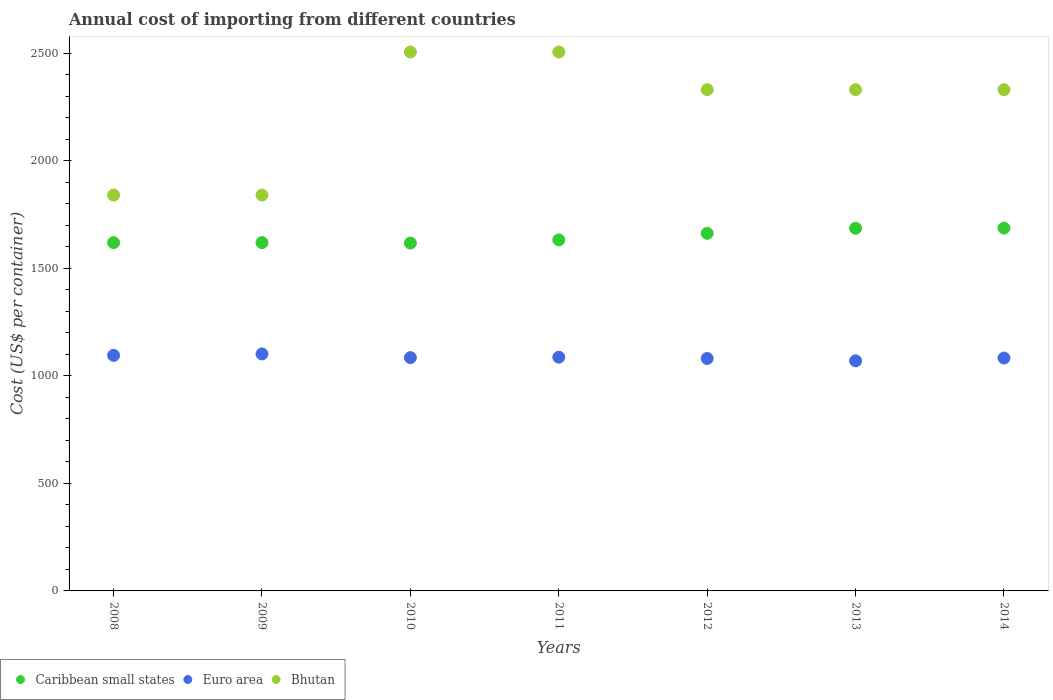How many different coloured dotlines are there?
Offer a very short reply. 3. Is the number of dotlines equal to the number of legend labels?
Offer a terse response. Yes. What is the total annual cost of importing in Caribbean small states in 2014?
Your response must be concise. 1686.54. Across all years, what is the maximum total annual cost of importing in Euro area?
Offer a terse response. 1101.44. Across all years, what is the minimum total annual cost of importing in Caribbean small states?
Your response must be concise. 1616.92. In which year was the total annual cost of importing in Caribbean small states maximum?
Provide a short and direct response. 2014. In which year was the total annual cost of importing in Bhutan minimum?
Offer a terse response. 2008. What is the total total annual cost of importing in Bhutan in the graph?
Ensure brevity in your answer.  1.57e+04. What is the difference between the total annual cost of importing in Caribbean small states in 2013 and that in 2014?
Provide a short and direct response. -0.77. What is the difference between the total annual cost of importing in Bhutan in 2013 and the total annual cost of importing in Euro area in 2012?
Make the answer very short. 1249.58. What is the average total annual cost of importing in Euro area per year?
Ensure brevity in your answer.  1085.68. In the year 2014, what is the difference between the total annual cost of importing in Euro area and total annual cost of importing in Bhutan?
Your answer should be compact. -1247.53. In how many years, is the total annual cost of importing in Euro area greater than 900 US$?
Keep it short and to the point. 7. What is the ratio of the total annual cost of importing in Euro area in 2012 to that in 2014?
Provide a succinct answer. 1. Is the total annual cost of importing in Caribbean small states in 2008 less than that in 2010?
Provide a short and direct response. No. What is the difference between the highest and the second highest total annual cost of importing in Euro area?
Provide a succinct answer. 6.5. What is the difference between the highest and the lowest total annual cost of importing in Euro area?
Give a very brief answer. 31.87. In how many years, is the total annual cost of importing in Bhutan greater than the average total annual cost of importing in Bhutan taken over all years?
Your response must be concise. 5. Is the sum of the total annual cost of importing in Bhutan in 2011 and 2013 greater than the maximum total annual cost of importing in Euro area across all years?
Give a very brief answer. Yes. Is it the case that in every year, the sum of the total annual cost of importing in Caribbean small states and total annual cost of importing in Bhutan  is greater than the total annual cost of importing in Euro area?
Your response must be concise. Yes. Is the total annual cost of importing in Bhutan strictly less than the total annual cost of importing in Caribbean small states over the years?
Make the answer very short. No. How many dotlines are there?
Ensure brevity in your answer.  3. How many years are there in the graph?
Your answer should be very brief. 7. What is the difference between two consecutive major ticks on the Y-axis?
Provide a short and direct response. 500. Does the graph contain any zero values?
Offer a terse response. No. Does the graph contain grids?
Keep it short and to the point. No. How many legend labels are there?
Give a very brief answer. 3. How are the legend labels stacked?
Ensure brevity in your answer.  Horizontal. What is the title of the graph?
Provide a succinct answer. Annual cost of importing from different countries. Does "Turks and Caicos Islands" appear as one of the legend labels in the graph?
Give a very brief answer. No. What is the label or title of the X-axis?
Offer a very short reply. Years. What is the label or title of the Y-axis?
Offer a very short reply. Cost (US$ per container). What is the Cost (US$ per container) in Caribbean small states in 2008?
Ensure brevity in your answer.  1619. What is the Cost (US$ per container) in Euro area in 2008?
Make the answer very short. 1094.94. What is the Cost (US$ per container) of Bhutan in 2008?
Provide a short and direct response. 1840. What is the Cost (US$ per container) in Caribbean small states in 2009?
Provide a short and direct response. 1619. What is the Cost (US$ per container) of Euro area in 2009?
Ensure brevity in your answer.  1101.44. What is the Cost (US$ per container) of Bhutan in 2009?
Ensure brevity in your answer.  1840. What is the Cost (US$ per container) in Caribbean small states in 2010?
Your answer should be very brief. 1616.92. What is the Cost (US$ per container) in Euro area in 2010?
Offer a terse response. 1084.44. What is the Cost (US$ per container) of Bhutan in 2010?
Offer a terse response. 2505. What is the Cost (US$ per container) in Caribbean small states in 2011?
Keep it short and to the point. 1631.77. What is the Cost (US$ per container) in Euro area in 2011?
Offer a very short reply. 1086.47. What is the Cost (US$ per container) in Bhutan in 2011?
Ensure brevity in your answer.  2505. What is the Cost (US$ per container) of Caribbean small states in 2012?
Ensure brevity in your answer.  1662.31. What is the Cost (US$ per container) of Euro area in 2012?
Provide a short and direct response. 1080.42. What is the Cost (US$ per container) in Bhutan in 2012?
Ensure brevity in your answer.  2330. What is the Cost (US$ per container) in Caribbean small states in 2013?
Offer a very short reply. 1685.77. What is the Cost (US$ per container) in Euro area in 2013?
Ensure brevity in your answer.  1069.58. What is the Cost (US$ per container) in Bhutan in 2013?
Keep it short and to the point. 2330. What is the Cost (US$ per container) in Caribbean small states in 2014?
Offer a terse response. 1686.54. What is the Cost (US$ per container) of Euro area in 2014?
Make the answer very short. 1082.47. What is the Cost (US$ per container) of Bhutan in 2014?
Your response must be concise. 2330. Across all years, what is the maximum Cost (US$ per container) in Caribbean small states?
Your answer should be very brief. 1686.54. Across all years, what is the maximum Cost (US$ per container) of Euro area?
Offer a very short reply. 1101.44. Across all years, what is the maximum Cost (US$ per container) of Bhutan?
Keep it short and to the point. 2505. Across all years, what is the minimum Cost (US$ per container) in Caribbean small states?
Keep it short and to the point. 1616.92. Across all years, what is the minimum Cost (US$ per container) of Euro area?
Offer a terse response. 1069.58. Across all years, what is the minimum Cost (US$ per container) in Bhutan?
Give a very brief answer. 1840. What is the total Cost (US$ per container) in Caribbean small states in the graph?
Provide a succinct answer. 1.15e+04. What is the total Cost (US$ per container) of Euro area in the graph?
Ensure brevity in your answer.  7599.78. What is the total Cost (US$ per container) of Bhutan in the graph?
Keep it short and to the point. 1.57e+04. What is the difference between the Cost (US$ per container) in Bhutan in 2008 and that in 2009?
Keep it short and to the point. 0. What is the difference between the Cost (US$ per container) in Caribbean small states in 2008 and that in 2010?
Ensure brevity in your answer.  2.08. What is the difference between the Cost (US$ per container) in Euro area in 2008 and that in 2010?
Offer a very short reply. 10.5. What is the difference between the Cost (US$ per container) in Bhutan in 2008 and that in 2010?
Provide a short and direct response. -665. What is the difference between the Cost (US$ per container) in Caribbean small states in 2008 and that in 2011?
Give a very brief answer. -12.77. What is the difference between the Cost (US$ per container) in Euro area in 2008 and that in 2011?
Make the answer very short. 8.47. What is the difference between the Cost (US$ per container) of Bhutan in 2008 and that in 2011?
Your response must be concise. -665. What is the difference between the Cost (US$ per container) of Caribbean small states in 2008 and that in 2012?
Your answer should be very brief. -43.31. What is the difference between the Cost (US$ per container) of Euro area in 2008 and that in 2012?
Give a very brief answer. 14.52. What is the difference between the Cost (US$ per container) in Bhutan in 2008 and that in 2012?
Keep it short and to the point. -490. What is the difference between the Cost (US$ per container) in Caribbean small states in 2008 and that in 2013?
Your response must be concise. -66.77. What is the difference between the Cost (US$ per container) of Euro area in 2008 and that in 2013?
Your response must be concise. 25.37. What is the difference between the Cost (US$ per container) of Bhutan in 2008 and that in 2013?
Offer a terse response. -490. What is the difference between the Cost (US$ per container) in Caribbean small states in 2008 and that in 2014?
Your answer should be very brief. -67.54. What is the difference between the Cost (US$ per container) in Euro area in 2008 and that in 2014?
Your answer should be compact. 12.47. What is the difference between the Cost (US$ per container) in Bhutan in 2008 and that in 2014?
Provide a short and direct response. -490. What is the difference between the Cost (US$ per container) of Caribbean small states in 2009 and that in 2010?
Give a very brief answer. 2.08. What is the difference between the Cost (US$ per container) in Euro area in 2009 and that in 2010?
Offer a very short reply. 17. What is the difference between the Cost (US$ per container) of Bhutan in 2009 and that in 2010?
Ensure brevity in your answer.  -665. What is the difference between the Cost (US$ per container) of Caribbean small states in 2009 and that in 2011?
Ensure brevity in your answer.  -12.77. What is the difference between the Cost (US$ per container) of Euro area in 2009 and that in 2011?
Your answer should be very brief. 14.97. What is the difference between the Cost (US$ per container) in Bhutan in 2009 and that in 2011?
Offer a terse response. -665. What is the difference between the Cost (US$ per container) in Caribbean small states in 2009 and that in 2012?
Provide a succinct answer. -43.31. What is the difference between the Cost (US$ per container) of Euro area in 2009 and that in 2012?
Offer a very short reply. 21.02. What is the difference between the Cost (US$ per container) in Bhutan in 2009 and that in 2012?
Provide a short and direct response. -490. What is the difference between the Cost (US$ per container) of Caribbean small states in 2009 and that in 2013?
Offer a very short reply. -66.77. What is the difference between the Cost (US$ per container) of Euro area in 2009 and that in 2013?
Offer a terse response. 31.87. What is the difference between the Cost (US$ per container) in Bhutan in 2009 and that in 2013?
Your answer should be compact. -490. What is the difference between the Cost (US$ per container) of Caribbean small states in 2009 and that in 2014?
Make the answer very short. -67.54. What is the difference between the Cost (US$ per container) of Euro area in 2009 and that in 2014?
Offer a terse response. 18.97. What is the difference between the Cost (US$ per container) in Bhutan in 2009 and that in 2014?
Offer a very short reply. -490. What is the difference between the Cost (US$ per container) of Caribbean small states in 2010 and that in 2011?
Make the answer very short. -14.85. What is the difference between the Cost (US$ per container) of Euro area in 2010 and that in 2011?
Offer a terse response. -2.03. What is the difference between the Cost (US$ per container) in Caribbean small states in 2010 and that in 2012?
Provide a succinct answer. -45.39. What is the difference between the Cost (US$ per container) of Euro area in 2010 and that in 2012?
Ensure brevity in your answer.  4.02. What is the difference between the Cost (US$ per container) of Bhutan in 2010 and that in 2012?
Provide a succinct answer. 175. What is the difference between the Cost (US$ per container) of Caribbean small states in 2010 and that in 2013?
Your answer should be compact. -68.85. What is the difference between the Cost (US$ per container) in Euro area in 2010 and that in 2013?
Provide a short and direct response. 14.87. What is the difference between the Cost (US$ per container) of Bhutan in 2010 and that in 2013?
Ensure brevity in your answer.  175. What is the difference between the Cost (US$ per container) in Caribbean small states in 2010 and that in 2014?
Provide a short and direct response. -69.62. What is the difference between the Cost (US$ per container) in Euro area in 2010 and that in 2014?
Your answer should be very brief. 1.97. What is the difference between the Cost (US$ per container) in Bhutan in 2010 and that in 2014?
Keep it short and to the point. 175. What is the difference between the Cost (US$ per container) of Caribbean small states in 2011 and that in 2012?
Keep it short and to the point. -30.54. What is the difference between the Cost (US$ per container) in Euro area in 2011 and that in 2012?
Offer a very short reply. 6.05. What is the difference between the Cost (US$ per container) in Bhutan in 2011 and that in 2012?
Ensure brevity in your answer.  175. What is the difference between the Cost (US$ per container) in Caribbean small states in 2011 and that in 2013?
Offer a terse response. -54. What is the difference between the Cost (US$ per container) of Euro area in 2011 and that in 2013?
Offer a very short reply. 16.89. What is the difference between the Cost (US$ per container) in Bhutan in 2011 and that in 2013?
Your answer should be compact. 175. What is the difference between the Cost (US$ per container) of Caribbean small states in 2011 and that in 2014?
Provide a short and direct response. -54.77. What is the difference between the Cost (US$ per container) of Bhutan in 2011 and that in 2014?
Provide a short and direct response. 175. What is the difference between the Cost (US$ per container) in Caribbean small states in 2012 and that in 2013?
Give a very brief answer. -23.46. What is the difference between the Cost (US$ per container) of Euro area in 2012 and that in 2013?
Offer a very short reply. 10.84. What is the difference between the Cost (US$ per container) of Caribbean small states in 2012 and that in 2014?
Offer a very short reply. -24.23. What is the difference between the Cost (US$ per container) of Euro area in 2012 and that in 2014?
Your answer should be compact. -2.05. What is the difference between the Cost (US$ per container) of Bhutan in 2012 and that in 2014?
Make the answer very short. 0. What is the difference between the Cost (US$ per container) of Caribbean small states in 2013 and that in 2014?
Keep it short and to the point. -0.77. What is the difference between the Cost (US$ per container) of Euro area in 2013 and that in 2014?
Your response must be concise. -12.89. What is the difference between the Cost (US$ per container) in Bhutan in 2013 and that in 2014?
Your answer should be very brief. 0. What is the difference between the Cost (US$ per container) of Caribbean small states in 2008 and the Cost (US$ per container) of Euro area in 2009?
Offer a very short reply. 517.56. What is the difference between the Cost (US$ per container) in Caribbean small states in 2008 and the Cost (US$ per container) in Bhutan in 2009?
Ensure brevity in your answer.  -221. What is the difference between the Cost (US$ per container) of Euro area in 2008 and the Cost (US$ per container) of Bhutan in 2009?
Provide a succinct answer. -745.06. What is the difference between the Cost (US$ per container) of Caribbean small states in 2008 and the Cost (US$ per container) of Euro area in 2010?
Make the answer very short. 534.56. What is the difference between the Cost (US$ per container) in Caribbean small states in 2008 and the Cost (US$ per container) in Bhutan in 2010?
Offer a very short reply. -886. What is the difference between the Cost (US$ per container) of Euro area in 2008 and the Cost (US$ per container) of Bhutan in 2010?
Offer a very short reply. -1410.06. What is the difference between the Cost (US$ per container) of Caribbean small states in 2008 and the Cost (US$ per container) of Euro area in 2011?
Offer a terse response. 532.53. What is the difference between the Cost (US$ per container) of Caribbean small states in 2008 and the Cost (US$ per container) of Bhutan in 2011?
Keep it short and to the point. -886. What is the difference between the Cost (US$ per container) in Euro area in 2008 and the Cost (US$ per container) in Bhutan in 2011?
Make the answer very short. -1410.06. What is the difference between the Cost (US$ per container) in Caribbean small states in 2008 and the Cost (US$ per container) in Euro area in 2012?
Your answer should be compact. 538.58. What is the difference between the Cost (US$ per container) in Caribbean small states in 2008 and the Cost (US$ per container) in Bhutan in 2012?
Your answer should be very brief. -711. What is the difference between the Cost (US$ per container) of Euro area in 2008 and the Cost (US$ per container) of Bhutan in 2012?
Offer a terse response. -1235.06. What is the difference between the Cost (US$ per container) of Caribbean small states in 2008 and the Cost (US$ per container) of Euro area in 2013?
Your answer should be compact. 549.42. What is the difference between the Cost (US$ per container) of Caribbean small states in 2008 and the Cost (US$ per container) of Bhutan in 2013?
Offer a very short reply. -711. What is the difference between the Cost (US$ per container) of Euro area in 2008 and the Cost (US$ per container) of Bhutan in 2013?
Make the answer very short. -1235.06. What is the difference between the Cost (US$ per container) of Caribbean small states in 2008 and the Cost (US$ per container) of Euro area in 2014?
Offer a very short reply. 536.53. What is the difference between the Cost (US$ per container) of Caribbean small states in 2008 and the Cost (US$ per container) of Bhutan in 2014?
Offer a terse response. -711. What is the difference between the Cost (US$ per container) of Euro area in 2008 and the Cost (US$ per container) of Bhutan in 2014?
Provide a short and direct response. -1235.06. What is the difference between the Cost (US$ per container) in Caribbean small states in 2009 and the Cost (US$ per container) in Euro area in 2010?
Your response must be concise. 534.56. What is the difference between the Cost (US$ per container) of Caribbean small states in 2009 and the Cost (US$ per container) of Bhutan in 2010?
Offer a very short reply. -886. What is the difference between the Cost (US$ per container) in Euro area in 2009 and the Cost (US$ per container) in Bhutan in 2010?
Keep it short and to the point. -1403.56. What is the difference between the Cost (US$ per container) of Caribbean small states in 2009 and the Cost (US$ per container) of Euro area in 2011?
Keep it short and to the point. 532.53. What is the difference between the Cost (US$ per container) of Caribbean small states in 2009 and the Cost (US$ per container) of Bhutan in 2011?
Make the answer very short. -886. What is the difference between the Cost (US$ per container) of Euro area in 2009 and the Cost (US$ per container) of Bhutan in 2011?
Your answer should be compact. -1403.56. What is the difference between the Cost (US$ per container) of Caribbean small states in 2009 and the Cost (US$ per container) of Euro area in 2012?
Your answer should be compact. 538.58. What is the difference between the Cost (US$ per container) in Caribbean small states in 2009 and the Cost (US$ per container) in Bhutan in 2012?
Your answer should be very brief. -711. What is the difference between the Cost (US$ per container) in Euro area in 2009 and the Cost (US$ per container) in Bhutan in 2012?
Ensure brevity in your answer.  -1228.56. What is the difference between the Cost (US$ per container) of Caribbean small states in 2009 and the Cost (US$ per container) of Euro area in 2013?
Provide a succinct answer. 549.42. What is the difference between the Cost (US$ per container) of Caribbean small states in 2009 and the Cost (US$ per container) of Bhutan in 2013?
Ensure brevity in your answer.  -711. What is the difference between the Cost (US$ per container) of Euro area in 2009 and the Cost (US$ per container) of Bhutan in 2013?
Offer a terse response. -1228.56. What is the difference between the Cost (US$ per container) of Caribbean small states in 2009 and the Cost (US$ per container) of Euro area in 2014?
Make the answer very short. 536.53. What is the difference between the Cost (US$ per container) of Caribbean small states in 2009 and the Cost (US$ per container) of Bhutan in 2014?
Provide a succinct answer. -711. What is the difference between the Cost (US$ per container) of Euro area in 2009 and the Cost (US$ per container) of Bhutan in 2014?
Offer a very short reply. -1228.56. What is the difference between the Cost (US$ per container) in Caribbean small states in 2010 and the Cost (US$ per container) in Euro area in 2011?
Provide a short and direct response. 530.44. What is the difference between the Cost (US$ per container) in Caribbean small states in 2010 and the Cost (US$ per container) in Bhutan in 2011?
Provide a succinct answer. -888.08. What is the difference between the Cost (US$ per container) in Euro area in 2010 and the Cost (US$ per container) in Bhutan in 2011?
Keep it short and to the point. -1420.56. What is the difference between the Cost (US$ per container) of Caribbean small states in 2010 and the Cost (US$ per container) of Euro area in 2012?
Your response must be concise. 536.5. What is the difference between the Cost (US$ per container) of Caribbean small states in 2010 and the Cost (US$ per container) of Bhutan in 2012?
Give a very brief answer. -713.08. What is the difference between the Cost (US$ per container) of Euro area in 2010 and the Cost (US$ per container) of Bhutan in 2012?
Provide a short and direct response. -1245.56. What is the difference between the Cost (US$ per container) of Caribbean small states in 2010 and the Cost (US$ per container) of Euro area in 2013?
Ensure brevity in your answer.  547.34. What is the difference between the Cost (US$ per container) in Caribbean small states in 2010 and the Cost (US$ per container) in Bhutan in 2013?
Provide a short and direct response. -713.08. What is the difference between the Cost (US$ per container) in Euro area in 2010 and the Cost (US$ per container) in Bhutan in 2013?
Your response must be concise. -1245.56. What is the difference between the Cost (US$ per container) of Caribbean small states in 2010 and the Cost (US$ per container) of Euro area in 2014?
Ensure brevity in your answer.  534.44. What is the difference between the Cost (US$ per container) in Caribbean small states in 2010 and the Cost (US$ per container) in Bhutan in 2014?
Your answer should be compact. -713.08. What is the difference between the Cost (US$ per container) of Euro area in 2010 and the Cost (US$ per container) of Bhutan in 2014?
Provide a short and direct response. -1245.56. What is the difference between the Cost (US$ per container) in Caribbean small states in 2011 and the Cost (US$ per container) in Euro area in 2012?
Provide a short and direct response. 551.35. What is the difference between the Cost (US$ per container) of Caribbean small states in 2011 and the Cost (US$ per container) of Bhutan in 2012?
Keep it short and to the point. -698.23. What is the difference between the Cost (US$ per container) in Euro area in 2011 and the Cost (US$ per container) in Bhutan in 2012?
Offer a terse response. -1243.53. What is the difference between the Cost (US$ per container) in Caribbean small states in 2011 and the Cost (US$ per container) in Euro area in 2013?
Your response must be concise. 562.19. What is the difference between the Cost (US$ per container) in Caribbean small states in 2011 and the Cost (US$ per container) in Bhutan in 2013?
Your response must be concise. -698.23. What is the difference between the Cost (US$ per container) in Euro area in 2011 and the Cost (US$ per container) in Bhutan in 2013?
Provide a succinct answer. -1243.53. What is the difference between the Cost (US$ per container) in Caribbean small states in 2011 and the Cost (US$ per container) in Euro area in 2014?
Your response must be concise. 549.3. What is the difference between the Cost (US$ per container) in Caribbean small states in 2011 and the Cost (US$ per container) in Bhutan in 2014?
Ensure brevity in your answer.  -698.23. What is the difference between the Cost (US$ per container) of Euro area in 2011 and the Cost (US$ per container) of Bhutan in 2014?
Provide a succinct answer. -1243.53. What is the difference between the Cost (US$ per container) of Caribbean small states in 2012 and the Cost (US$ per container) of Euro area in 2013?
Offer a very short reply. 592.73. What is the difference between the Cost (US$ per container) of Caribbean small states in 2012 and the Cost (US$ per container) of Bhutan in 2013?
Make the answer very short. -667.69. What is the difference between the Cost (US$ per container) of Euro area in 2012 and the Cost (US$ per container) of Bhutan in 2013?
Provide a succinct answer. -1249.58. What is the difference between the Cost (US$ per container) of Caribbean small states in 2012 and the Cost (US$ per container) of Euro area in 2014?
Provide a succinct answer. 579.83. What is the difference between the Cost (US$ per container) in Caribbean small states in 2012 and the Cost (US$ per container) in Bhutan in 2014?
Your answer should be compact. -667.69. What is the difference between the Cost (US$ per container) of Euro area in 2012 and the Cost (US$ per container) of Bhutan in 2014?
Your answer should be compact. -1249.58. What is the difference between the Cost (US$ per container) of Caribbean small states in 2013 and the Cost (US$ per container) of Euro area in 2014?
Offer a terse response. 603.3. What is the difference between the Cost (US$ per container) in Caribbean small states in 2013 and the Cost (US$ per container) in Bhutan in 2014?
Make the answer very short. -644.23. What is the difference between the Cost (US$ per container) of Euro area in 2013 and the Cost (US$ per container) of Bhutan in 2014?
Give a very brief answer. -1260.42. What is the average Cost (US$ per container) of Caribbean small states per year?
Offer a very short reply. 1645.9. What is the average Cost (US$ per container) of Euro area per year?
Offer a very short reply. 1085.68. What is the average Cost (US$ per container) of Bhutan per year?
Your answer should be compact. 2240. In the year 2008, what is the difference between the Cost (US$ per container) in Caribbean small states and Cost (US$ per container) in Euro area?
Your response must be concise. 524.06. In the year 2008, what is the difference between the Cost (US$ per container) of Caribbean small states and Cost (US$ per container) of Bhutan?
Provide a short and direct response. -221. In the year 2008, what is the difference between the Cost (US$ per container) in Euro area and Cost (US$ per container) in Bhutan?
Your response must be concise. -745.06. In the year 2009, what is the difference between the Cost (US$ per container) in Caribbean small states and Cost (US$ per container) in Euro area?
Provide a succinct answer. 517.56. In the year 2009, what is the difference between the Cost (US$ per container) in Caribbean small states and Cost (US$ per container) in Bhutan?
Provide a succinct answer. -221. In the year 2009, what is the difference between the Cost (US$ per container) in Euro area and Cost (US$ per container) in Bhutan?
Offer a very short reply. -738.56. In the year 2010, what is the difference between the Cost (US$ per container) in Caribbean small states and Cost (US$ per container) in Euro area?
Your answer should be compact. 532.47. In the year 2010, what is the difference between the Cost (US$ per container) of Caribbean small states and Cost (US$ per container) of Bhutan?
Make the answer very short. -888.08. In the year 2010, what is the difference between the Cost (US$ per container) of Euro area and Cost (US$ per container) of Bhutan?
Provide a short and direct response. -1420.56. In the year 2011, what is the difference between the Cost (US$ per container) of Caribbean small states and Cost (US$ per container) of Euro area?
Provide a short and direct response. 545.3. In the year 2011, what is the difference between the Cost (US$ per container) in Caribbean small states and Cost (US$ per container) in Bhutan?
Your answer should be compact. -873.23. In the year 2011, what is the difference between the Cost (US$ per container) of Euro area and Cost (US$ per container) of Bhutan?
Provide a short and direct response. -1418.53. In the year 2012, what is the difference between the Cost (US$ per container) of Caribbean small states and Cost (US$ per container) of Euro area?
Provide a succinct answer. 581.89. In the year 2012, what is the difference between the Cost (US$ per container) of Caribbean small states and Cost (US$ per container) of Bhutan?
Make the answer very short. -667.69. In the year 2012, what is the difference between the Cost (US$ per container) of Euro area and Cost (US$ per container) of Bhutan?
Provide a succinct answer. -1249.58. In the year 2013, what is the difference between the Cost (US$ per container) of Caribbean small states and Cost (US$ per container) of Euro area?
Give a very brief answer. 616.19. In the year 2013, what is the difference between the Cost (US$ per container) in Caribbean small states and Cost (US$ per container) in Bhutan?
Your response must be concise. -644.23. In the year 2013, what is the difference between the Cost (US$ per container) of Euro area and Cost (US$ per container) of Bhutan?
Ensure brevity in your answer.  -1260.42. In the year 2014, what is the difference between the Cost (US$ per container) in Caribbean small states and Cost (US$ per container) in Euro area?
Your answer should be compact. 604.06. In the year 2014, what is the difference between the Cost (US$ per container) in Caribbean small states and Cost (US$ per container) in Bhutan?
Your answer should be compact. -643.46. In the year 2014, what is the difference between the Cost (US$ per container) in Euro area and Cost (US$ per container) in Bhutan?
Your answer should be very brief. -1247.53. What is the ratio of the Cost (US$ per container) in Caribbean small states in 2008 to that in 2009?
Make the answer very short. 1. What is the ratio of the Cost (US$ per container) in Euro area in 2008 to that in 2009?
Provide a succinct answer. 0.99. What is the ratio of the Cost (US$ per container) of Euro area in 2008 to that in 2010?
Your answer should be compact. 1.01. What is the ratio of the Cost (US$ per container) in Bhutan in 2008 to that in 2010?
Provide a short and direct response. 0.73. What is the ratio of the Cost (US$ per container) of Caribbean small states in 2008 to that in 2011?
Your answer should be very brief. 0.99. What is the ratio of the Cost (US$ per container) of Bhutan in 2008 to that in 2011?
Provide a succinct answer. 0.73. What is the ratio of the Cost (US$ per container) in Caribbean small states in 2008 to that in 2012?
Offer a very short reply. 0.97. What is the ratio of the Cost (US$ per container) of Euro area in 2008 to that in 2012?
Keep it short and to the point. 1.01. What is the ratio of the Cost (US$ per container) in Bhutan in 2008 to that in 2012?
Your answer should be very brief. 0.79. What is the ratio of the Cost (US$ per container) in Caribbean small states in 2008 to that in 2013?
Your answer should be compact. 0.96. What is the ratio of the Cost (US$ per container) in Euro area in 2008 to that in 2013?
Provide a short and direct response. 1.02. What is the ratio of the Cost (US$ per container) in Bhutan in 2008 to that in 2013?
Offer a terse response. 0.79. What is the ratio of the Cost (US$ per container) of Caribbean small states in 2008 to that in 2014?
Your answer should be very brief. 0.96. What is the ratio of the Cost (US$ per container) in Euro area in 2008 to that in 2014?
Give a very brief answer. 1.01. What is the ratio of the Cost (US$ per container) in Bhutan in 2008 to that in 2014?
Give a very brief answer. 0.79. What is the ratio of the Cost (US$ per container) in Caribbean small states in 2009 to that in 2010?
Ensure brevity in your answer.  1. What is the ratio of the Cost (US$ per container) of Euro area in 2009 to that in 2010?
Offer a very short reply. 1.02. What is the ratio of the Cost (US$ per container) in Bhutan in 2009 to that in 2010?
Ensure brevity in your answer.  0.73. What is the ratio of the Cost (US$ per container) in Caribbean small states in 2009 to that in 2011?
Give a very brief answer. 0.99. What is the ratio of the Cost (US$ per container) in Euro area in 2009 to that in 2011?
Provide a short and direct response. 1.01. What is the ratio of the Cost (US$ per container) of Bhutan in 2009 to that in 2011?
Your answer should be compact. 0.73. What is the ratio of the Cost (US$ per container) in Caribbean small states in 2009 to that in 2012?
Your response must be concise. 0.97. What is the ratio of the Cost (US$ per container) of Euro area in 2009 to that in 2012?
Provide a succinct answer. 1.02. What is the ratio of the Cost (US$ per container) in Bhutan in 2009 to that in 2012?
Give a very brief answer. 0.79. What is the ratio of the Cost (US$ per container) in Caribbean small states in 2009 to that in 2013?
Keep it short and to the point. 0.96. What is the ratio of the Cost (US$ per container) in Euro area in 2009 to that in 2013?
Give a very brief answer. 1.03. What is the ratio of the Cost (US$ per container) in Bhutan in 2009 to that in 2013?
Make the answer very short. 0.79. What is the ratio of the Cost (US$ per container) in Euro area in 2009 to that in 2014?
Ensure brevity in your answer.  1.02. What is the ratio of the Cost (US$ per container) in Bhutan in 2009 to that in 2014?
Your response must be concise. 0.79. What is the ratio of the Cost (US$ per container) of Caribbean small states in 2010 to that in 2011?
Make the answer very short. 0.99. What is the ratio of the Cost (US$ per container) of Euro area in 2010 to that in 2011?
Your response must be concise. 1. What is the ratio of the Cost (US$ per container) of Bhutan in 2010 to that in 2011?
Ensure brevity in your answer.  1. What is the ratio of the Cost (US$ per container) in Caribbean small states in 2010 to that in 2012?
Your response must be concise. 0.97. What is the ratio of the Cost (US$ per container) in Bhutan in 2010 to that in 2012?
Give a very brief answer. 1.08. What is the ratio of the Cost (US$ per container) in Caribbean small states in 2010 to that in 2013?
Offer a terse response. 0.96. What is the ratio of the Cost (US$ per container) in Euro area in 2010 to that in 2013?
Offer a terse response. 1.01. What is the ratio of the Cost (US$ per container) of Bhutan in 2010 to that in 2013?
Give a very brief answer. 1.08. What is the ratio of the Cost (US$ per container) in Caribbean small states in 2010 to that in 2014?
Provide a succinct answer. 0.96. What is the ratio of the Cost (US$ per container) of Bhutan in 2010 to that in 2014?
Keep it short and to the point. 1.08. What is the ratio of the Cost (US$ per container) in Caribbean small states in 2011 to that in 2012?
Your answer should be very brief. 0.98. What is the ratio of the Cost (US$ per container) in Euro area in 2011 to that in 2012?
Offer a terse response. 1.01. What is the ratio of the Cost (US$ per container) of Bhutan in 2011 to that in 2012?
Your response must be concise. 1.08. What is the ratio of the Cost (US$ per container) of Euro area in 2011 to that in 2013?
Your response must be concise. 1.02. What is the ratio of the Cost (US$ per container) in Bhutan in 2011 to that in 2013?
Keep it short and to the point. 1.08. What is the ratio of the Cost (US$ per container) in Caribbean small states in 2011 to that in 2014?
Provide a short and direct response. 0.97. What is the ratio of the Cost (US$ per container) in Euro area in 2011 to that in 2014?
Provide a short and direct response. 1. What is the ratio of the Cost (US$ per container) in Bhutan in 2011 to that in 2014?
Make the answer very short. 1.08. What is the ratio of the Cost (US$ per container) of Caribbean small states in 2012 to that in 2013?
Provide a succinct answer. 0.99. What is the ratio of the Cost (US$ per container) of Euro area in 2012 to that in 2013?
Offer a very short reply. 1.01. What is the ratio of the Cost (US$ per container) in Caribbean small states in 2012 to that in 2014?
Make the answer very short. 0.99. What is the ratio of the Cost (US$ per container) in Euro area in 2012 to that in 2014?
Offer a terse response. 1. What is the ratio of the Cost (US$ per container) of Bhutan in 2013 to that in 2014?
Offer a very short reply. 1. What is the difference between the highest and the second highest Cost (US$ per container) in Caribbean small states?
Your answer should be compact. 0.77. What is the difference between the highest and the second highest Cost (US$ per container) of Euro area?
Offer a terse response. 6.5. What is the difference between the highest and the lowest Cost (US$ per container) in Caribbean small states?
Offer a terse response. 69.62. What is the difference between the highest and the lowest Cost (US$ per container) of Euro area?
Offer a terse response. 31.87. What is the difference between the highest and the lowest Cost (US$ per container) of Bhutan?
Keep it short and to the point. 665. 